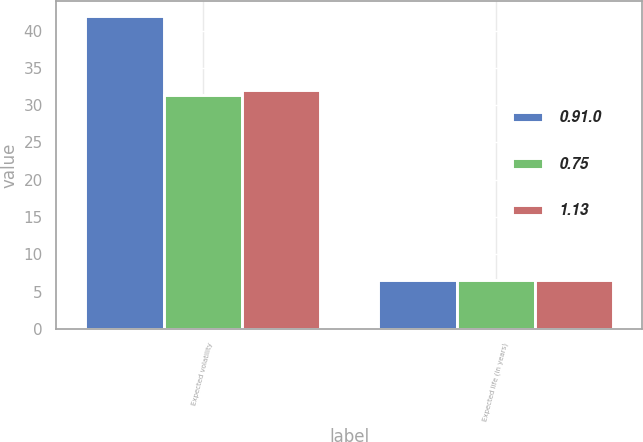Convert chart to OTSL. <chart><loc_0><loc_0><loc_500><loc_500><stacked_bar_chart><ecel><fcel>Expected volatility<fcel>Expected life (in years)<nl><fcel>0.91.0<fcel>41.9<fcel>6.5<nl><fcel>0.75<fcel>31.3<fcel>6.5<nl><fcel>1.13<fcel>32<fcel>6.5<nl></chart> 